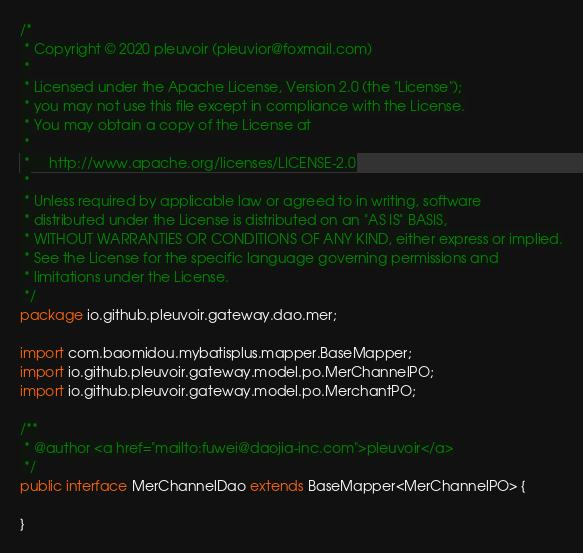<code> <loc_0><loc_0><loc_500><loc_500><_Java_>/*
 * Copyright © 2020 pleuvoir (pleuvior@foxmail.com)
 *
 * Licensed under the Apache License, Version 2.0 (the "License");
 * you may not use this file except in compliance with the License.
 * You may obtain a copy of the License at
 *
 *     http://www.apache.org/licenses/LICENSE-2.0
 *
 * Unless required by applicable law or agreed to in writing, software
 * distributed under the License is distributed on an "AS IS" BASIS,
 * WITHOUT WARRANTIES OR CONDITIONS OF ANY KIND, either express or implied.
 * See the License for the specific language governing permissions and
 * limitations under the License.
 */
package io.github.pleuvoir.gateway.dao.mer;

import com.baomidou.mybatisplus.mapper.BaseMapper;
import io.github.pleuvoir.gateway.model.po.MerChannelPO;
import io.github.pleuvoir.gateway.model.po.MerchantPO;

/**
 * @author <a href="mailto:fuwei@daojia-inc.com">pleuvoir</a>
 */
public interface MerChannelDao extends BaseMapper<MerChannelPO> {

}
</code> 